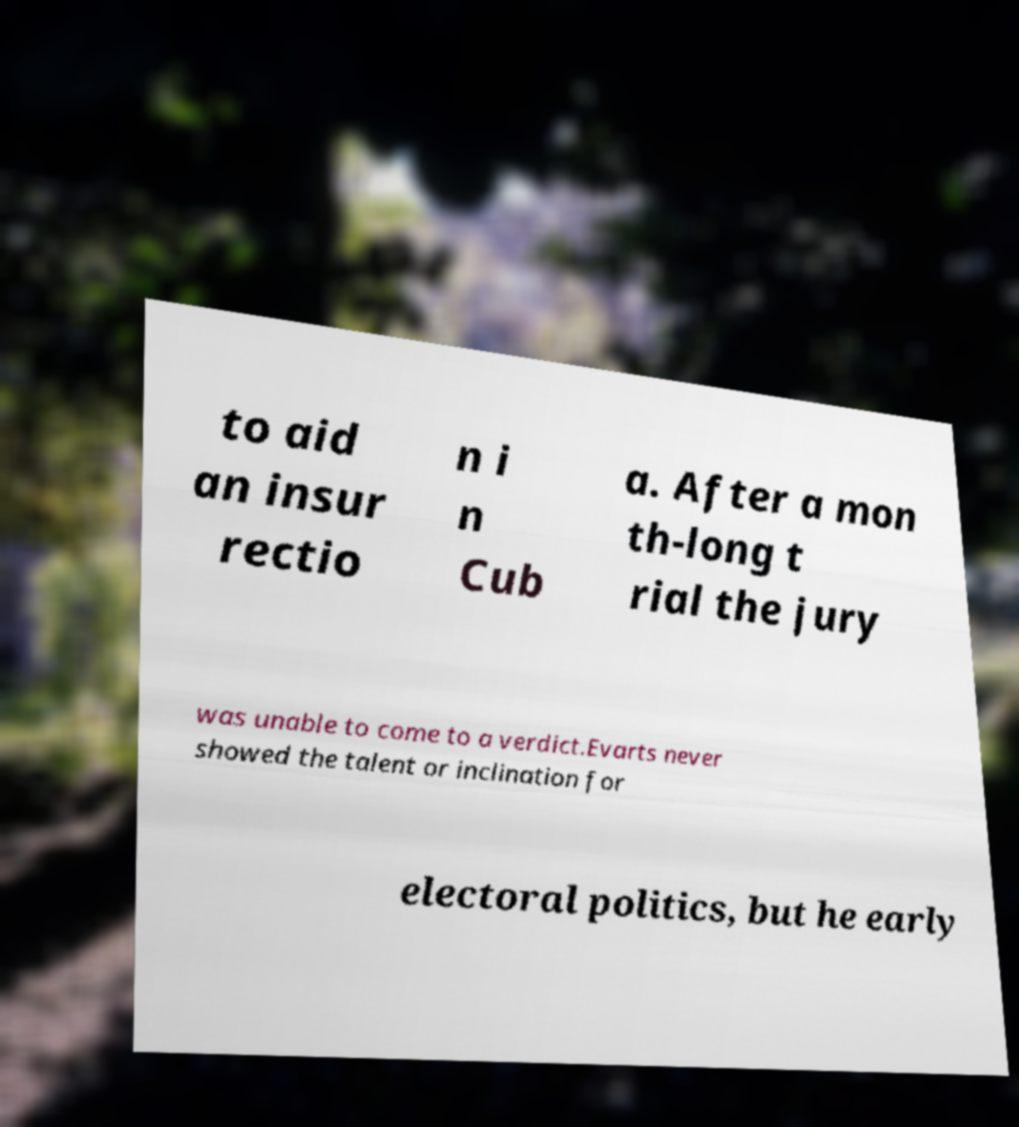Could you extract and type out the text from this image? to aid an insur rectio n i n Cub a. After a mon th-long t rial the jury was unable to come to a verdict.Evarts never showed the talent or inclination for electoral politics, but he early 